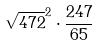Convert formula to latex. <formula><loc_0><loc_0><loc_500><loc_500>\sqrt { 4 7 2 } ^ { 2 } \cdot \frac { 2 4 7 } { 6 5 }</formula> 